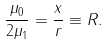Convert formula to latex. <formula><loc_0><loc_0><loc_500><loc_500>\frac { \mu _ { 0 } } { 2 \mu _ { 1 } } = \frac { x } { r } \equiv R .</formula> 